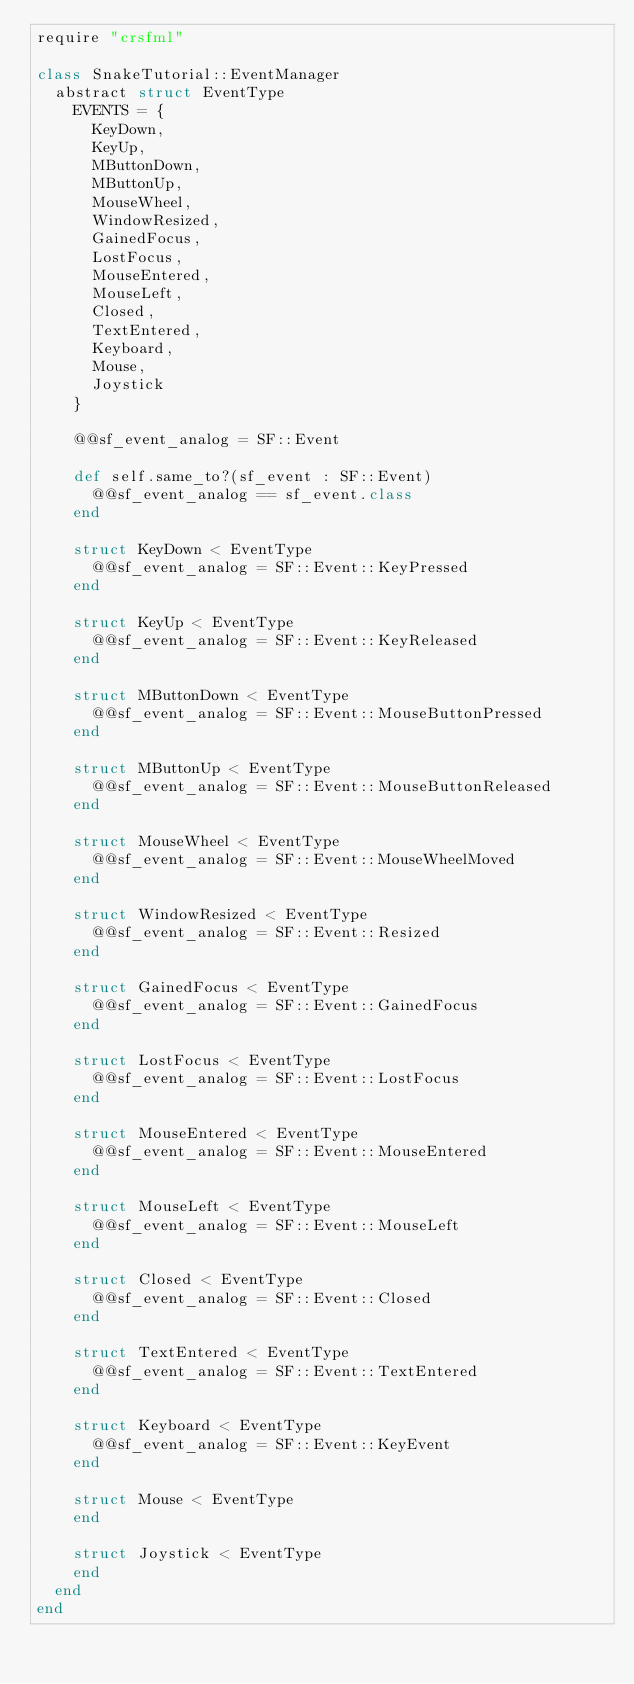Convert code to text. <code><loc_0><loc_0><loc_500><loc_500><_Crystal_>require "crsfml"

class SnakeTutorial::EventManager
  abstract struct EventType
    EVENTS = {
      KeyDown,
      KeyUp,
      MButtonDown,
      MButtonUp,
      MouseWheel,
      WindowResized,
      GainedFocus,
      LostFocus,
      MouseEntered,
      MouseLeft,
      Closed,
      TextEntered,
      Keyboard,
      Mouse,
      Joystick
    }

    @@sf_event_analog = SF::Event

    def self.same_to?(sf_event : SF::Event)
      @@sf_event_analog == sf_event.class
    end

    struct KeyDown < EventType
      @@sf_event_analog = SF::Event::KeyPressed
    end

    struct KeyUp < EventType
      @@sf_event_analog = SF::Event::KeyReleased
    end

    struct MButtonDown < EventType
      @@sf_event_analog = SF::Event::MouseButtonPressed
    end

    struct MButtonUp < EventType
      @@sf_event_analog = SF::Event::MouseButtonReleased
    end

    struct MouseWheel < EventType
      @@sf_event_analog = SF::Event::MouseWheelMoved
    end

    struct WindowResized < EventType
      @@sf_event_analog = SF::Event::Resized
    end

    struct GainedFocus < EventType
      @@sf_event_analog = SF::Event::GainedFocus
    end

    struct LostFocus < EventType
      @@sf_event_analog = SF::Event::LostFocus
    end

    struct MouseEntered < EventType
      @@sf_event_analog = SF::Event::MouseEntered
    end

    struct MouseLeft < EventType
      @@sf_event_analog = SF::Event::MouseLeft
    end

    struct Closed < EventType
      @@sf_event_analog = SF::Event::Closed
    end

    struct TextEntered < EventType
      @@sf_event_analog = SF::Event::TextEntered
    end

    struct Keyboard < EventType
      @@sf_event_analog = SF::Event::KeyEvent
    end

    struct Mouse < EventType
    end

    struct Joystick < EventType
    end
  end
end
</code> 